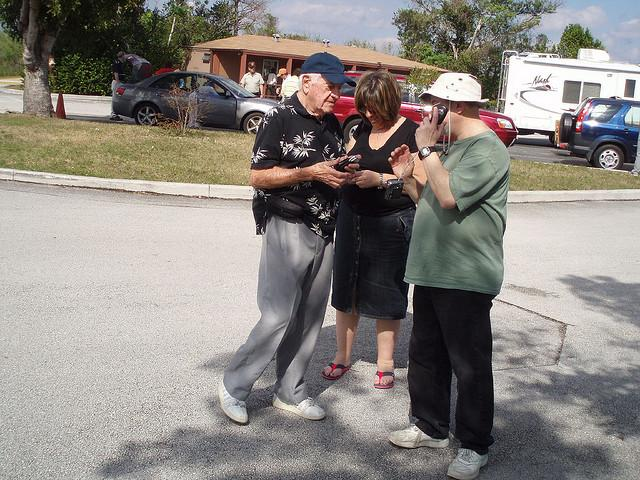Which person is the oldest?

Choices:
A) right man
B) middle woman
C) left man
D) back man left man 